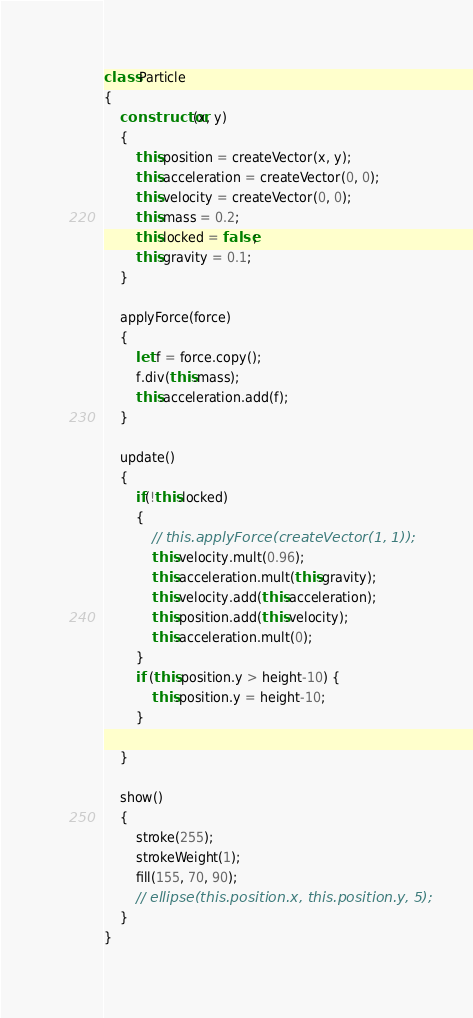<code> <loc_0><loc_0><loc_500><loc_500><_JavaScript_>class Particle
{
    constructor(x, y)
    {
        this.position = createVector(x, y);
        this.acceleration = createVector(0, 0);
        this.velocity = createVector(0, 0);
        this.mass = 0.2;
        this.locked = false;
        this.gravity = 0.1;
    }

    applyForce(force)
    {
        let f = force.copy();
        f.div(this.mass);
        this.acceleration.add(f);
    }

    update()
    {
        if(!this.locked)
        {
            // this.applyForce(createVector(1, 1));
            this.velocity.mult(0.96);
            this.acceleration.mult(this.gravity);
            this.velocity.add(this.acceleration);
            this.position.add(this.velocity);
            this.acceleration.mult(0);
        }
        if (this.position.y > height-10) {
            this.position.y = height-10;
        }
        
    }

    show()
    {
        stroke(255);
        strokeWeight(1);
        fill(155, 70, 90);
        // ellipse(this.position.x, this.position.y, 5);
    }
}</code> 